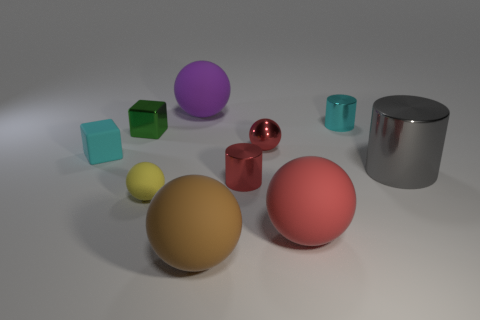What size is the thing that is the same color as the rubber cube?
Ensure brevity in your answer.  Small. What number of cylinders are the same size as the brown matte ball?
Provide a short and direct response. 1. There is a shiny thing that is the same color as the rubber block; what shape is it?
Your answer should be very brief. Cylinder. How many objects are either small red cylinders that are in front of the gray shiny cylinder or tiny spheres?
Make the answer very short. 3. Is the number of gray cylinders less than the number of large spheres?
Your answer should be compact. Yes. There is a big brown thing that is made of the same material as the yellow object; what is its shape?
Provide a short and direct response. Sphere. Are there any yellow matte spheres behind the cyan shiny thing?
Provide a succinct answer. No. Are there fewer purple spheres that are in front of the purple rubber thing than tiny purple matte spheres?
Offer a terse response. No. What is the brown thing made of?
Offer a terse response. Rubber. What is the color of the small matte ball?
Your answer should be very brief. Yellow. 